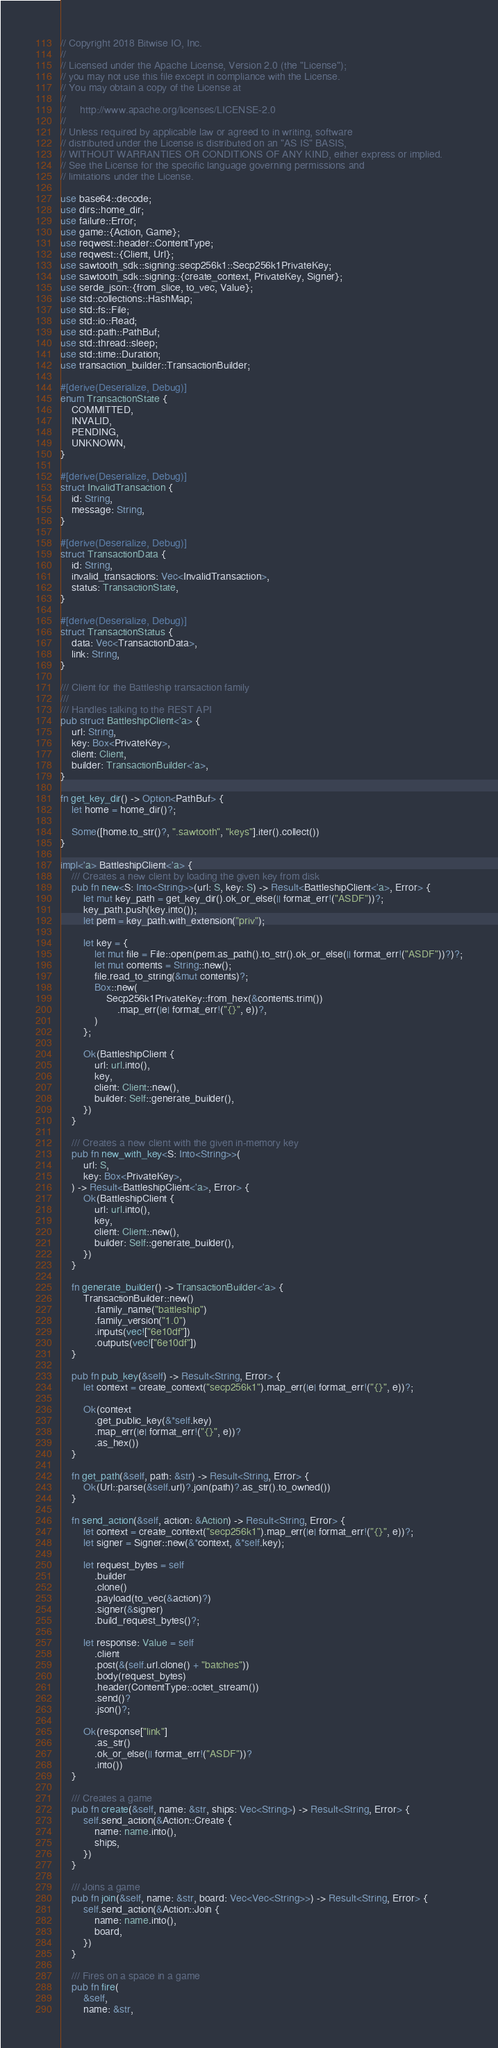Convert code to text. <code><loc_0><loc_0><loc_500><loc_500><_Rust_>// Copyright 2018 Bitwise IO, Inc.
//
// Licensed under the Apache License, Version 2.0 (the "License");
// you may not use this file except in compliance with the License.
// You may obtain a copy of the License at
//
//     http://www.apache.org/licenses/LICENSE-2.0
//
// Unless required by applicable law or agreed to in writing, software
// distributed under the License is distributed on an "AS IS" BASIS,
// WITHOUT WARRANTIES OR CONDITIONS OF ANY KIND, either express or implied.
// See the License for the specific language governing permissions and
// limitations under the License.

use base64::decode;
use dirs::home_dir;
use failure::Error;
use game::{Action, Game};
use reqwest::header::ContentType;
use reqwest::{Client, Url};
use sawtooth_sdk::signing::secp256k1::Secp256k1PrivateKey;
use sawtooth_sdk::signing::{create_context, PrivateKey, Signer};
use serde_json::{from_slice, to_vec, Value};
use std::collections::HashMap;
use std::fs::File;
use std::io::Read;
use std::path::PathBuf;
use std::thread::sleep;
use std::time::Duration;
use transaction_builder::TransactionBuilder;

#[derive(Deserialize, Debug)]
enum TransactionState {
    COMMITTED,
    INVALID,
    PENDING,
    UNKNOWN,
}

#[derive(Deserialize, Debug)]
struct InvalidTransaction {
    id: String,
    message: String,
}

#[derive(Deserialize, Debug)]
struct TransactionData {
    id: String,
    invalid_transactions: Vec<InvalidTransaction>,
    status: TransactionState,
}

#[derive(Deserialize, Debug)]
struct TransactionStatus {
    data: Vec<TransactionData>,
    link: String,
}

/// Client for the Battleship transaction family
///
/// Handles talking to the REST API
pub struct BattleshipClient<'a> {
    url: String,
    key: Box<PrivateKey>,
    client: Client,
    builder: TransactionBuilder<'a>,
}

fn get_key_dir() -> Option<PathBuf> {
    let home = home_dir()?;

    Some([home.to_str()?, ".sawtooth", "keys"].iter().collect())
}

impl<'a> BattleshipClient<'a> {
    /// Creates a new client by loading the given key from disk
    pub fn new<S: Into<String>>(url: S, key: S) -> Result<BattleshipClient<'a>, Error> {
        let mut key_path = get_key_dir().ok_or_else(|| format_err!("ASDF"))?;
        key_path.push(key.into());
        let pem = key_path.with_extension("priv");

        let key = {
            let mut file = File::open(pem.as_path().to_str().ok_or_else(|| format_err!("ASDF"))?)?;
            let mut contents = String::new();
            file.read_to_string(&mut contents)?;
            Box::new(
                Secp256k1PrivateKey::from_hex(&contents.trim())
                    .map_err(|e| format_err!("{}", e))?,
            )
        };

        Ok(BattleshipClient {
            url: url.into(),
            key,
            client: Client::new(),
            builder: Self::generate_builder(),
        })
    }

    /// Creates a new client with the given in-memory key
    pub fn new_with_key<S: Into<String>>(
        url: S,
        key: Box<PrivateKey>,
    ) -> Result<BattleshipClient<'a>, Error> {
        Ok(BattleshipClient {
            url: url.into(),
            key,
            client: Client::new(),
            builder: Self::generate_builder(),
        })
    }

    fn generate_builder() -> TransactionBuilder<'a> {
        TransactionBuilder::new()
            .family_name("battleship")
            .family_version("1.0")
            .inputs(vec!["6e10df"])
            .outputs(vec!["6e10df"])
    }

    pub fn pub_key(&self) -> Result<String, Error> {
        let context = create_context("secp256k1").map_err(|e| format_err!("{}", e))?;

        Ok(context
            .get_public_key(&*self.key)
            .map_err(|e| format_err!("{}", e))?
            .as_hex())
    }

    fn get_path(&self, path: &str) -> Result<String, Error> {
        Ok(Url::parse(&self.url)?.join(path)?.as_str().to_owned())
    }

    fn send_action(&self, action: &Action) -> Result<String, Error> {
        let context = create_context("secp256k1").map_err(|e| format_err!("{}", e))?;
        let signer = Signer::new(&*context, &*self.key);

        let request_bytes = self
            .builder
            .clone()
            .payload(to_vec(&action)?)
            .signer(&signer)
            .build_request_bytes()?;

        let response: Value = self
            .client
            .post(&(self.url.clone() + "batches"))
            .body(request_bytes)
            .header(ContentType::octet_stream())
            .send()?
            .json()?;

        Ok(response["link"]
            .as_str()
            .ok_or_else(|| format_err!("ASDF"))?
            .into())
    }

    /// Creates a game
    pub fn create(&self, name: &str, ships: Vec<String>) -> Result<String, Error> {
        self.send_action(&Action::Create {
            name: name.into(),
            ships,
        })
    }

    /// Joins a game
    pub fn join(&self, name: &str, board: Vec<Vec<String>>) -> Result<String, Error> {
        self.send_action(&Action::Join {
            name: name.into(),
            board,
        })
    }

    /// Fires on a space in a game
    pub fn fire(
        &self,
        name: &str,</code> 